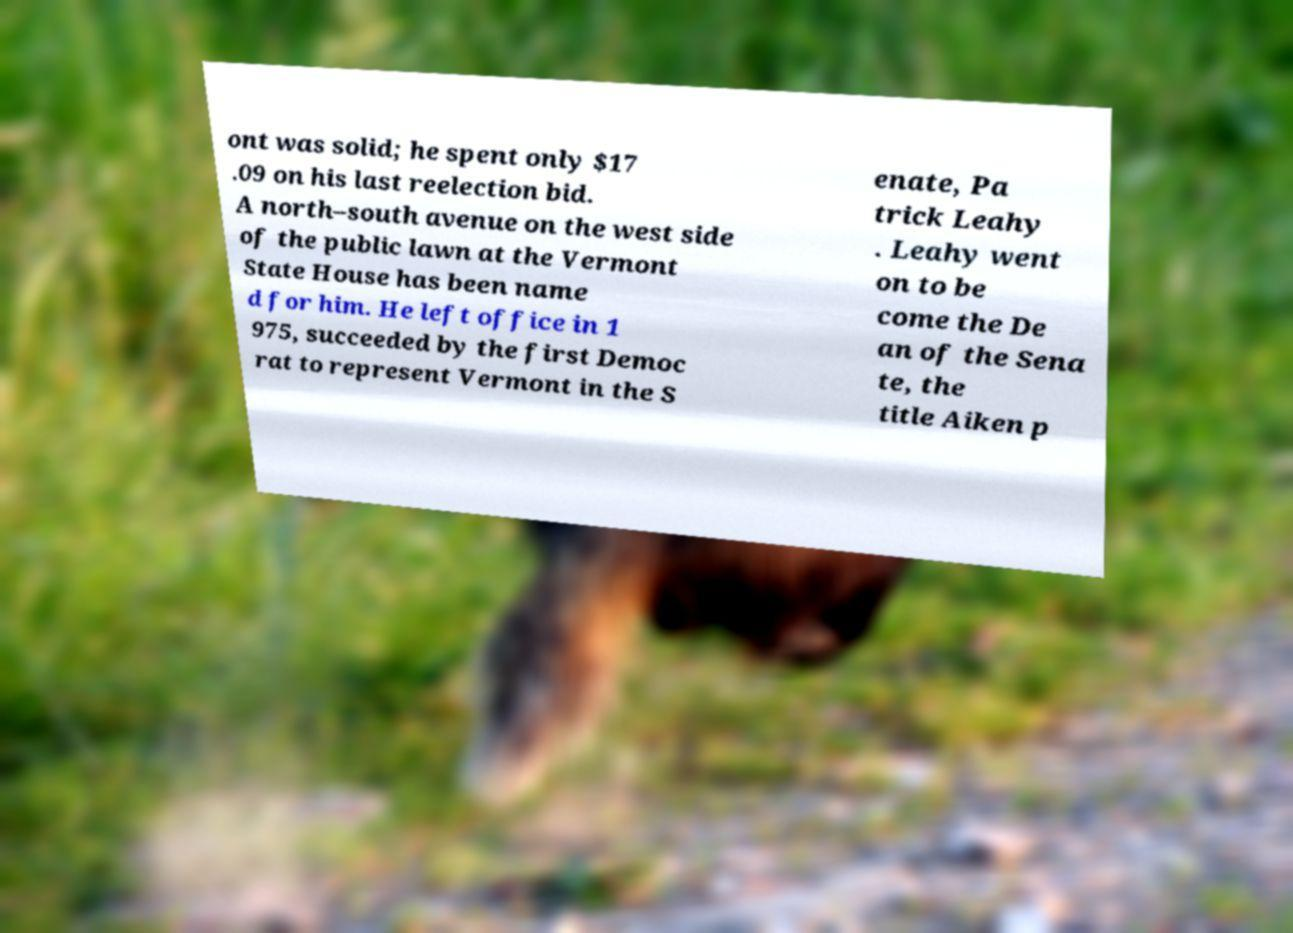Can you accurately transcribe the text from the provided image for me? ont was solid; he spent only $17 .09 on his last reelection bid. A north–south avenue on the west side of the public lawn at the Vermont State House has been name d for him. He left office in 1 975, succeeded by the first Democ rat to represent Vermont in the S enate, Pa trick Leahy . Leahy went on to be come the De an of the Sena te, the title Aiken p 